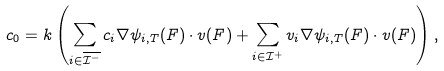Convert formula to latex. <formula><loc_0><loc_0><loc_500><loc_500>c _ { 0 } = k \left ( \sum _ { i \in \overline { \mathcal { I } ^ { - } } } c _ { i } \nabla \psi _ { i , T } ( F ) \cdot v ( F ) + \sum _ { i \in \mathcal { I } ^ { + } } v _ { i } \nabla \psi _ { i , T } ( F ) \cdot v ( F ) \right ) ,</formula> 